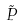<formula> <loc_0><loc_0><loc_500><loc_500>\tilde { P }</formula> 